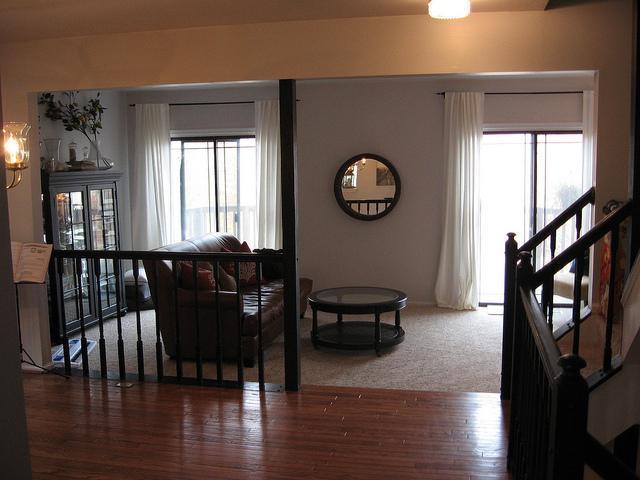How many couches are in the photo?
Give a very brief answer. 1. How many people are have board?
Give a very brief answer. 0. 